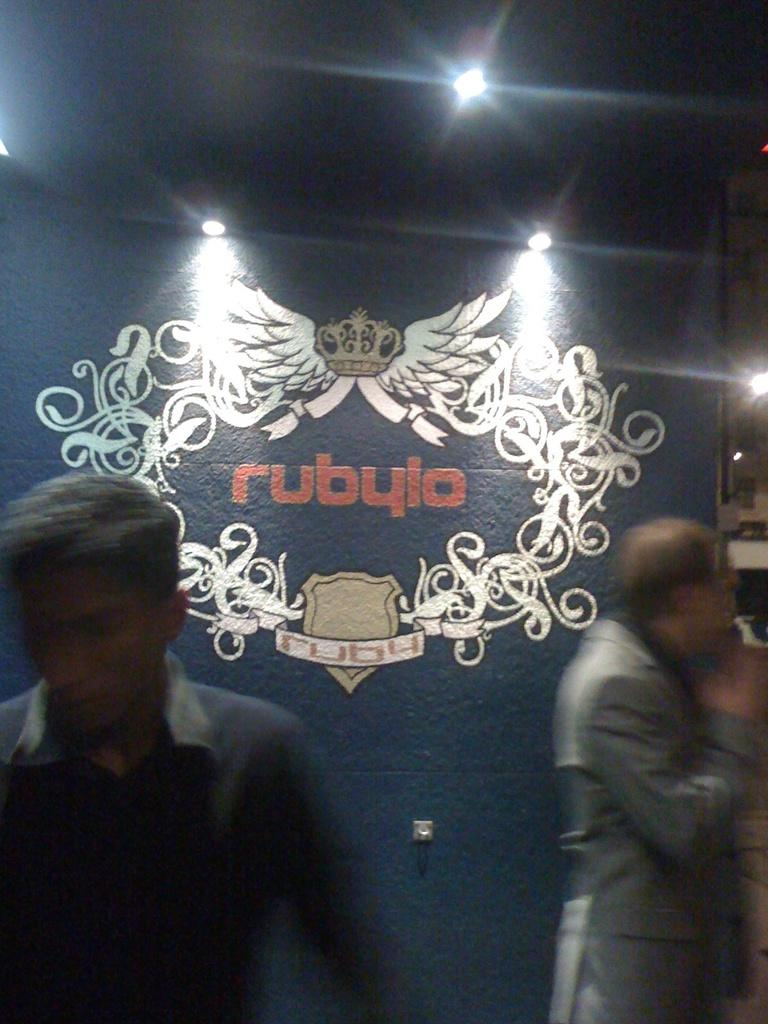Who or what is present in the image? There are people in the image. What can be seen on the wall in the background? There is an art piece on the wall in the background. What can be observed in terms of lighting in the image? There are lights visible in the image. What time of day is it in the image, specifically in the afternoon? The time of day cannot be determined from the image, as there is no indication of the time or the presence of the afternoon. 